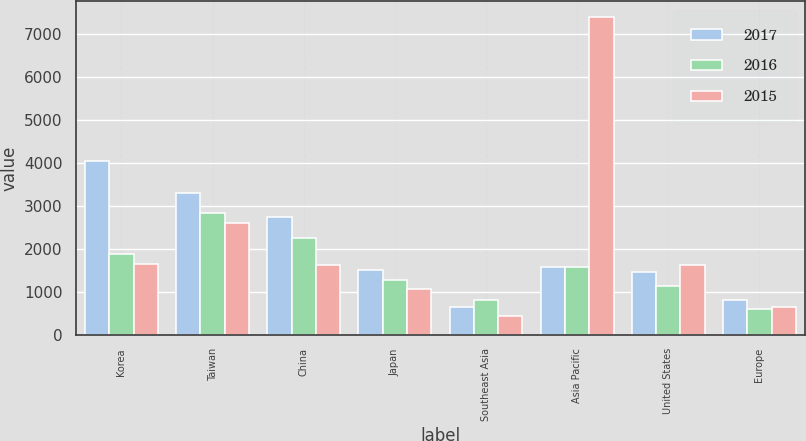Convert chart to OTSL. <chart><loc_0><loc_0><loc_500><loc_500><stacked_bar_chart><ecel><fcel>Korea<fcel>Taiwan<fcel>China<fcel>Japan<fcel>Southeast Asia<fcel>Asia Pacific<fcel>United States<fcel>Europe<nl><fcel>2017<fcel>4052<fcel>3291<fcel>2746<fcel>1518<fcel>640<fcel>1570.5<fcel>1474<fcel>816<nl><fcel>2016<fcel>1883<fcel>2843<fcel>2259<fcel>1279<fcel>803<fcel>1570.5<fcel>1143<fcel>615<nl><fcel>2015<fcel>1654<fcel>2600<fcel>1623<fcel>1078<fcel>432<fcel>7387<fcel>1630<fcel>642<nl></chart> 